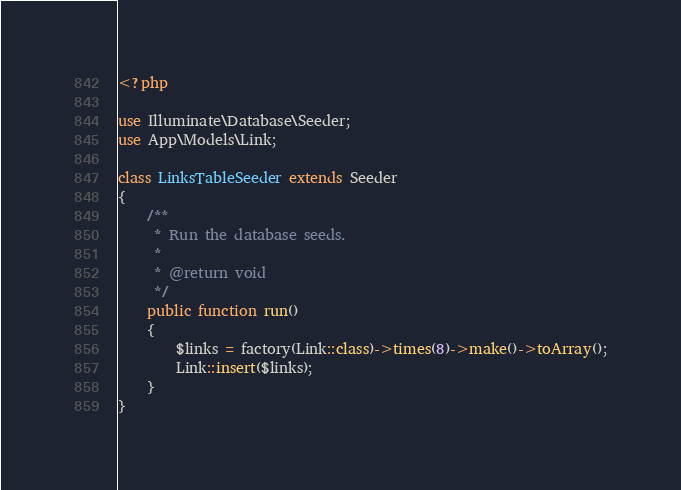Convert code to text. <code><loc_0><loc_0><loc_500><loc_500><_PHP_><?php

use Illuminate\Database\Seeder;
use App\Models\Link;

class LinksTableSeeder extends Seeder
{
    /**
     * Run the database seeds.
     *
     * @return void
     */
    public function run()
    {
        $links = factory(Link::class)->times(8)->make()->toArray();
        Link::insert($links);
    }
}
</code> 